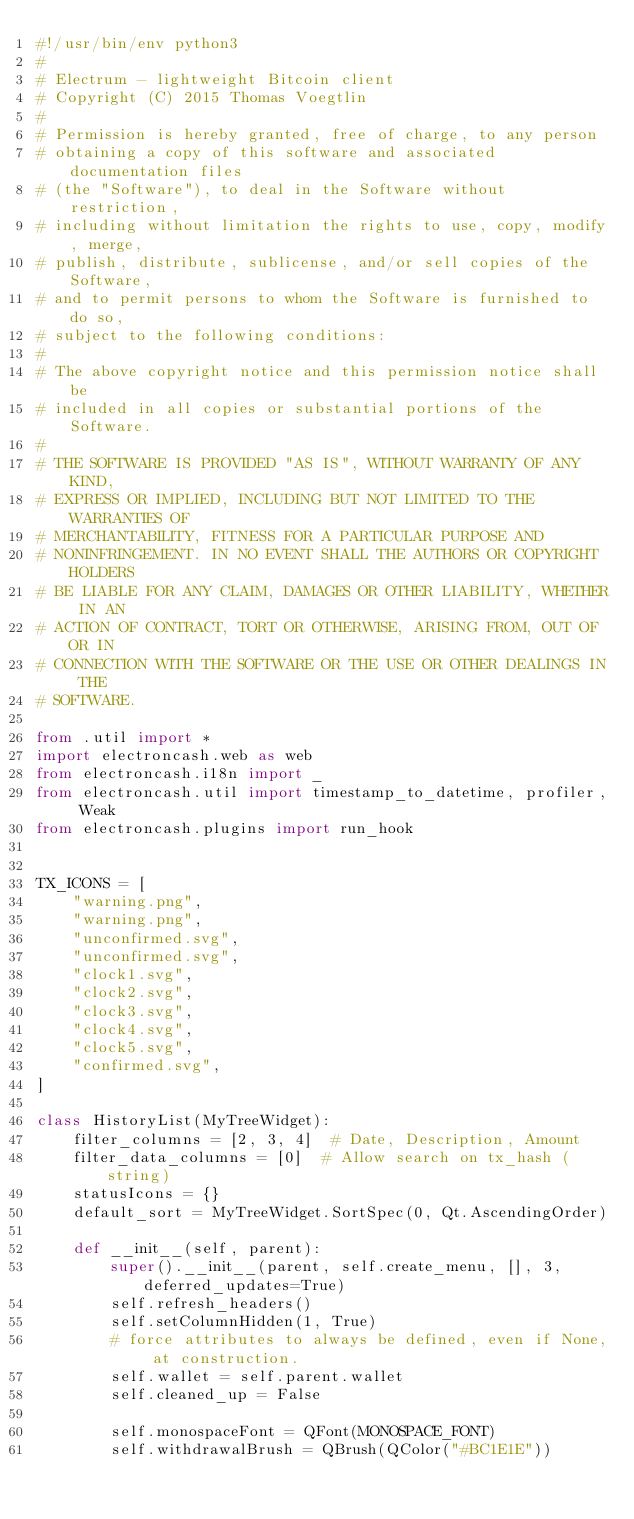<code> <loc_0><loc_0><loc_500><loc_500><_Python_>#!/usr/bin/env python3
#
# Electrum - lightweight Bitcoin client
# Copyright (C) 2015 Thomas Voegtlin
#
# Permission is hereby granted, free of charge, to any person
# obtaining a copy of this software and associated documentation files
# (the "Software"), to deal in the Software without restriction,
# including without limitation the rights to use, copy, modify, merge,
# publish, distribute, sublicense, and/or sell copies of the Software,
# and to permit persons to whom the Software is furnished to do so,
# subject to the following conditions:
#
# The above copyright notice and this permission notice shall be
# included in all copies or substantial portions of the Software.
#
# THE SOFTWARE IS PROVIDED "AS IS", WITHOUT WARRANTY OF ANY KIND,
# EXPRESS OR IMPLIED, INCLUDING BUT NOT LIMITED TO THE WARRANTIES OF
# MERCHANTABILITY, FITNESS FOR A PARTICULAR PURPOSE AND
# NONINFRINGEMENT. IN NO EVENT SHALL THE AUTHORS OR COPYRIGHT HOLDERS
# BE LIABLE FOR ANY CLAIM, DAMAGES OR OTHER LIABILITY, WHETHER IN AN
# ACTION OF CONTRACT, TORT OR OTHERWISE, ARISING FROM, OUT OF OR IN
# CONNECTION WITH THE SOFTWARE OR THE USE OR OTHER DEALINGS IN THE
# SOFTWARE.

from .util import *
import electroncash.web as web
from electroncash.i18n import _
from electroncash.util import timestamp_to_datetime, profiler, Weak
from electroncash.plugins import run_hook


TX_ICONS = [
    "warning.png",
    "warning.png",
    "unconfirmed.svg",
    "unconfirmed.svg",
    "clock1.svg",
    "clock2.svg",
    "clock3.svg",
    "clock4.svg",
    "clock5.svg",
    "confirmed.svg",
]

class HistoryList(MyTreeWidget):
    filter_columns = [2, 3, 4]  # Date, Description, Amount
    filter_data_columns = [0]  # Allow search on tx_hash (string)
    statusIcons = {}
    default_sort = MyTreeWidget.SortSpec(0, Qt.AscendingOrder)

    def __init__(self, parent):
        super().__init__(parent, self.create_menu, [], 3, deferred_updates=True)
        self.refresh_headers()
        self.setColumnHidden(1, True)
        # force attributes to always be defined, even if None, at construction.
        self.wallet = self.parent.wallet
        self.cleaned_up = False

        self.monospaceFont = QFont(MONOSPACE_FONT)
        self.withdrawalBrush = QBrush(QColor("#BC1E1E"))</code> 